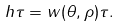Convert formula to latex. <formula><loc_0><loc_0><loc_500><loc_500>\ h \tau = w ( \theta , \rho ) \tau .</formula> 